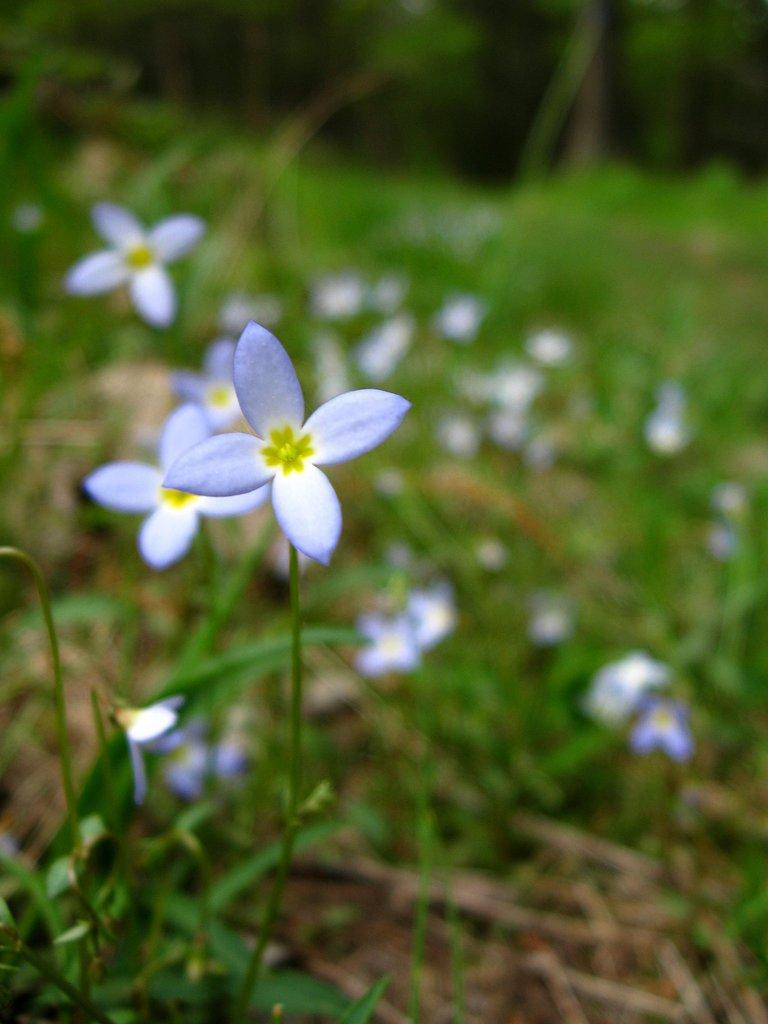What type of flower is in the image? There is a white flower in the image. How is the flower connected to its stem? The flower is attached to a green stem. What can be seen in the background of the image? There are flowers with plants in the background of the image. What type of ice can be seen melting around the flower in the image? There is no ice present in the image; it features a white flower with a green stem. 